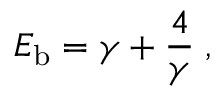Convert formula to latex. <formula><loc_0><loc_0><loc_500><loc_500>E _ { b } = \gamma + { \frac { 4 } { \gamma } } \, ,</formula> 